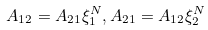<formula> <loc_0><loc_0><loc_500><loc_500>A _ { 1 2 } = A _ { 2 1 } \xi _ { 1 } ^ { N } , A _ { 2 1 } = A _ { 1 2 } \xi _ { 2 } ^ { N }</formula> 